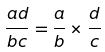<formula> <loc_0><loc_0><loc_500><loc_500>\frac { a d } { b c } = \frac { a } { b } \times \frac { d } { c }</formula> 